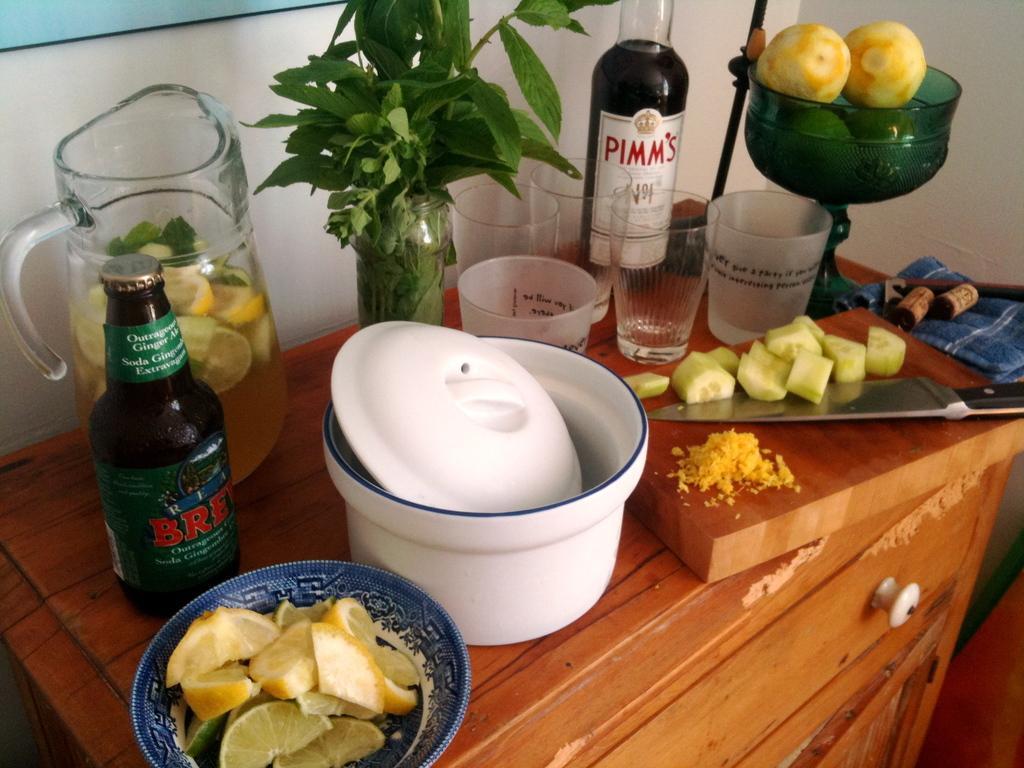Can you describe this image briefly? In this picture we can see a chopping board, some glasses, bottles, a plate, a jar, a flower vase in the front, we can see a knife and pieces of cucumber present on the chopping board, at the bottom there are draws, we can see pieces of orange in this plate, in the background there is a wall, on the right side we can see a cloth. 